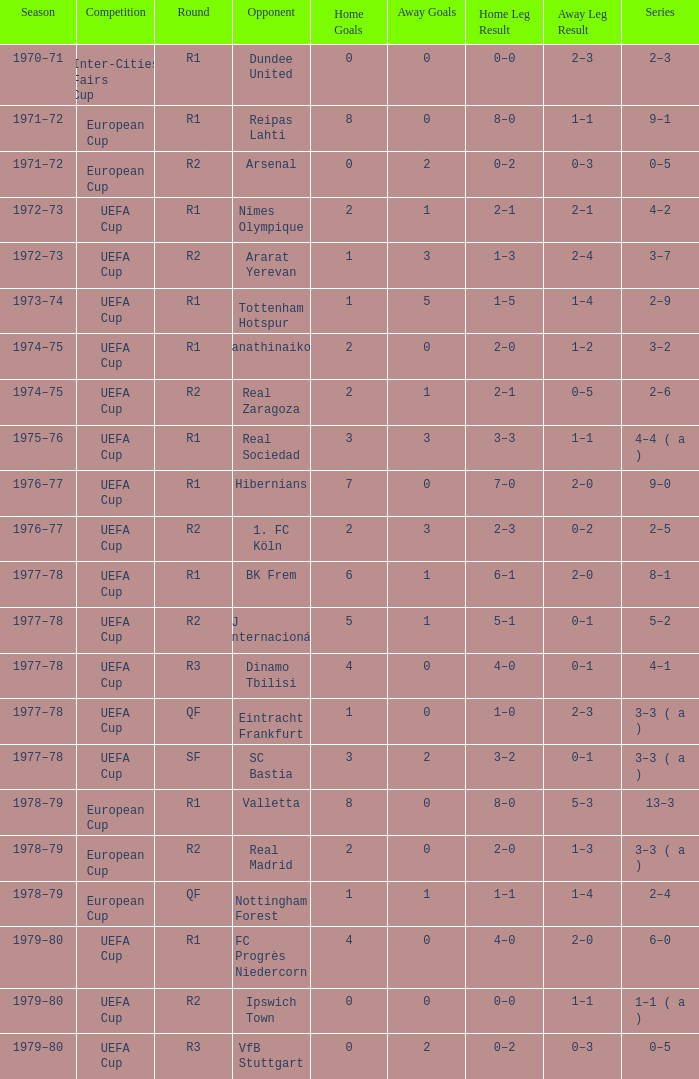Which household has a rotation of r1, and a competitor of dundee united? 0–0. 